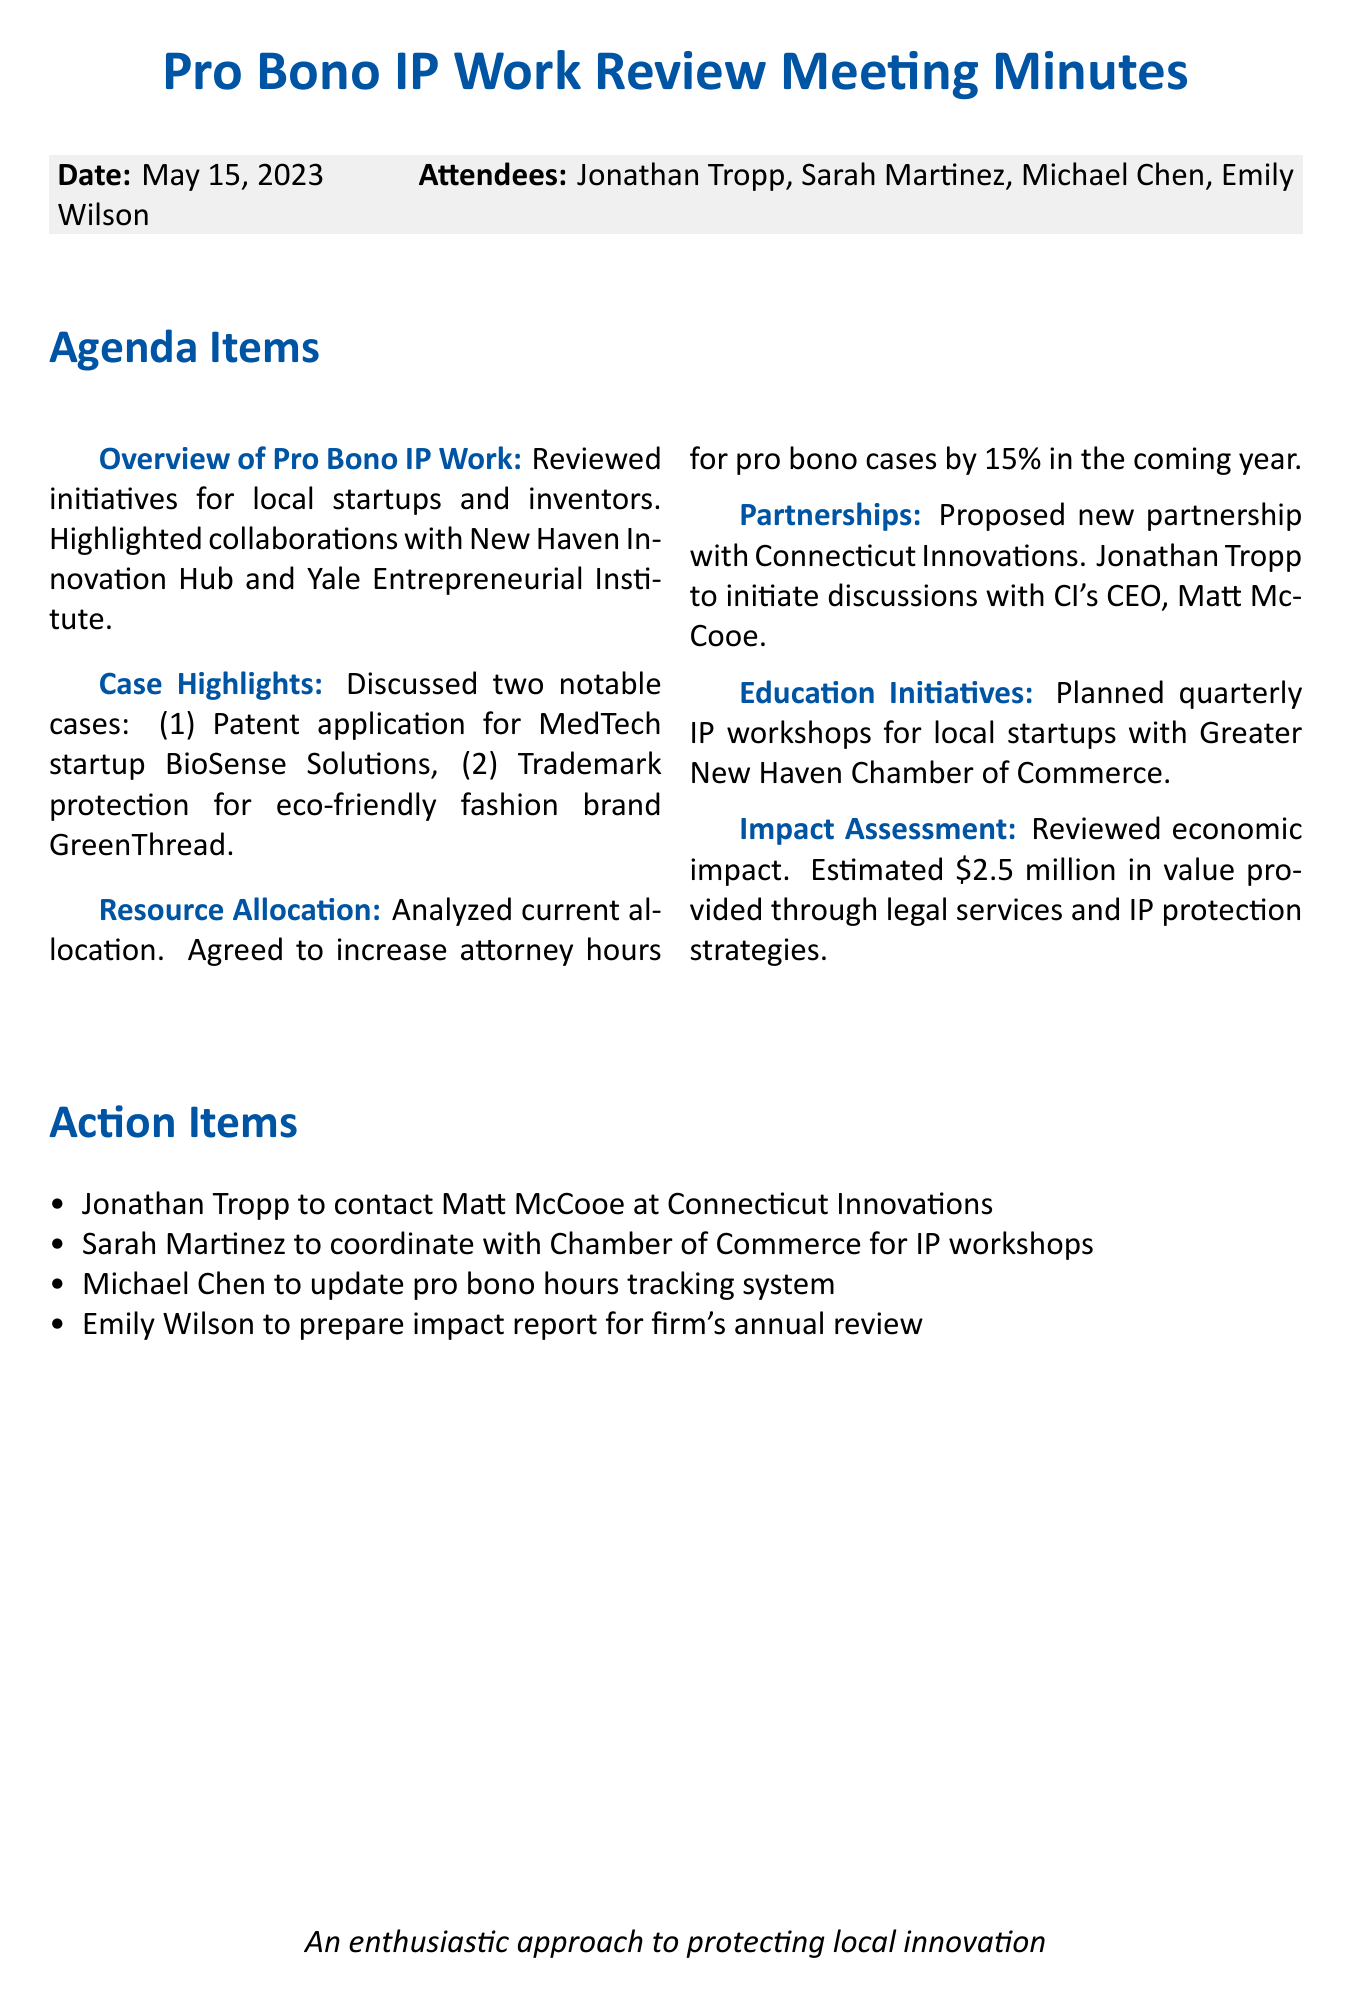what is the date of the meeting? The date of the meeting is explicitly stated in the document header.
Answer: May 15, 2023 who proposed the new partnership? The document identifies Jonathan Tropp as the person who proposed the new partnership in the "Partnerships" section.
Answer: Jonathan Tropp how many pro bono hours will be increased? The increase in pro bono hours is specified in the "Resource Allocation" section as a percentage.
Answer: 15% what is the estimated economic impact value provided through legal services? The "Impact Assessment" section calculates the economic impact value provided through legal services.
Answer: $2.5 million what are the topics planned for the quarterly IP workshops? The document lists the topics for the workshops in the "Education Initiatives" section.
Answer: patent basics, trademark protection, and IP strategy for startups who is responsible for preparing the impact report? The action items list identifies the person assigned to prepare the impact report.
Answer: Emily Wilson which two notable pro bono cases were discussed? The "Case Highlights" section mentions specific cases, providing insight into the focus of the pro bono work.
Answer: BioSense Solutions and GreenThread what organization will Sarah Martinez coordinate with? The action items section specifies the organization linked to the coordination task.
Answer: Chamber of Commerce 